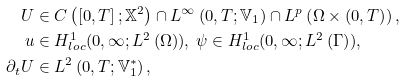<formula> <loc_0><loc_0><loc_500><loc_500>U & \in C \left ( \left [ 0 , T \right ] ; \mathbb { X } ^ { 2 } \right ) \cap L ^ { \infty } \left ( 0 , T ; \mathbb { V } _ { 1 } \right ) \cap L ^ { p } \left ( \Omega \times \left ( 0 , T \right ) \right ) , \\ u & \in H _ { l o c } ^ { 1 } ( 0 , \infty ; L ^ { 2 } \left ( \Omega \right ) ) , \text { } \psi \in H _ { l o c } ^ { 1 } ( 0 , \infty ; L ^ { 2 } \left ( \Gamma \right ) ) , \\ \partial _ { t } U & \in L ^ { 2 } \left ( 0 , T ; \mathbb { V } _ { 1 } ^ { \ast } \right ) ,</formula> 